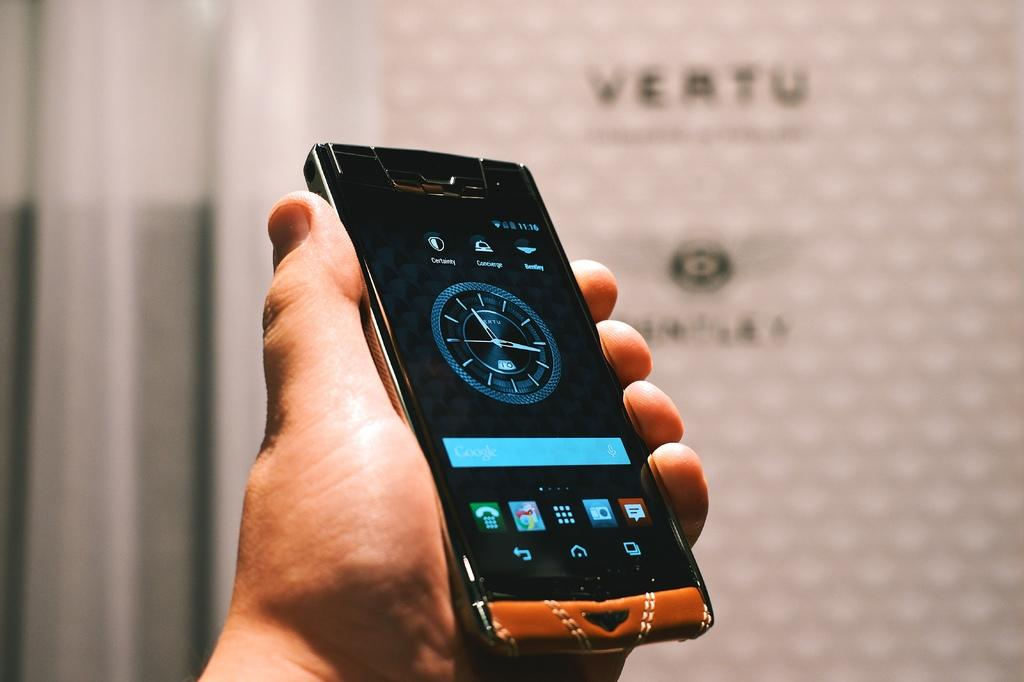Provide a one-sentence caption for the provided image. Vertu watch displayed on a phone in someone's hand. 